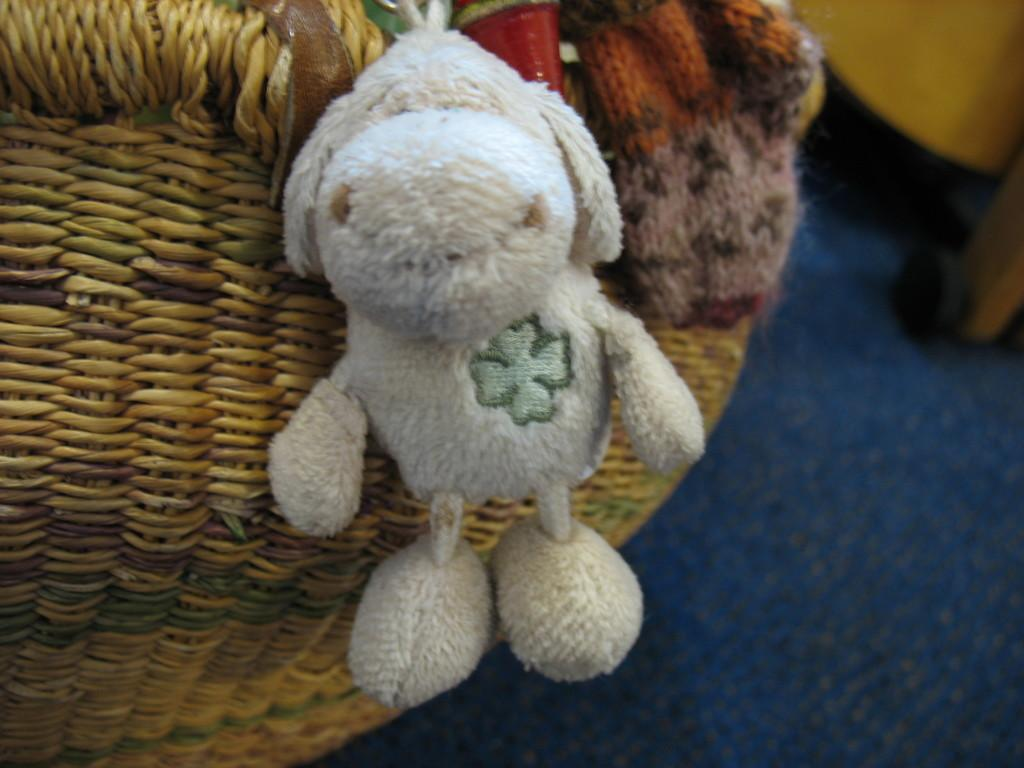What object can be seen in the image that is meant for play or amusement? There is a toy in the image. What color is the toy? The toy is white in color. What type of flooring is visible in the image? There is a carpet in the image. What type of container is present in the image? There is a basket in the image. Can you see the heartbeat of the toy in the image? There is no heartbeat or heart-related feature present in the toy or the image. 